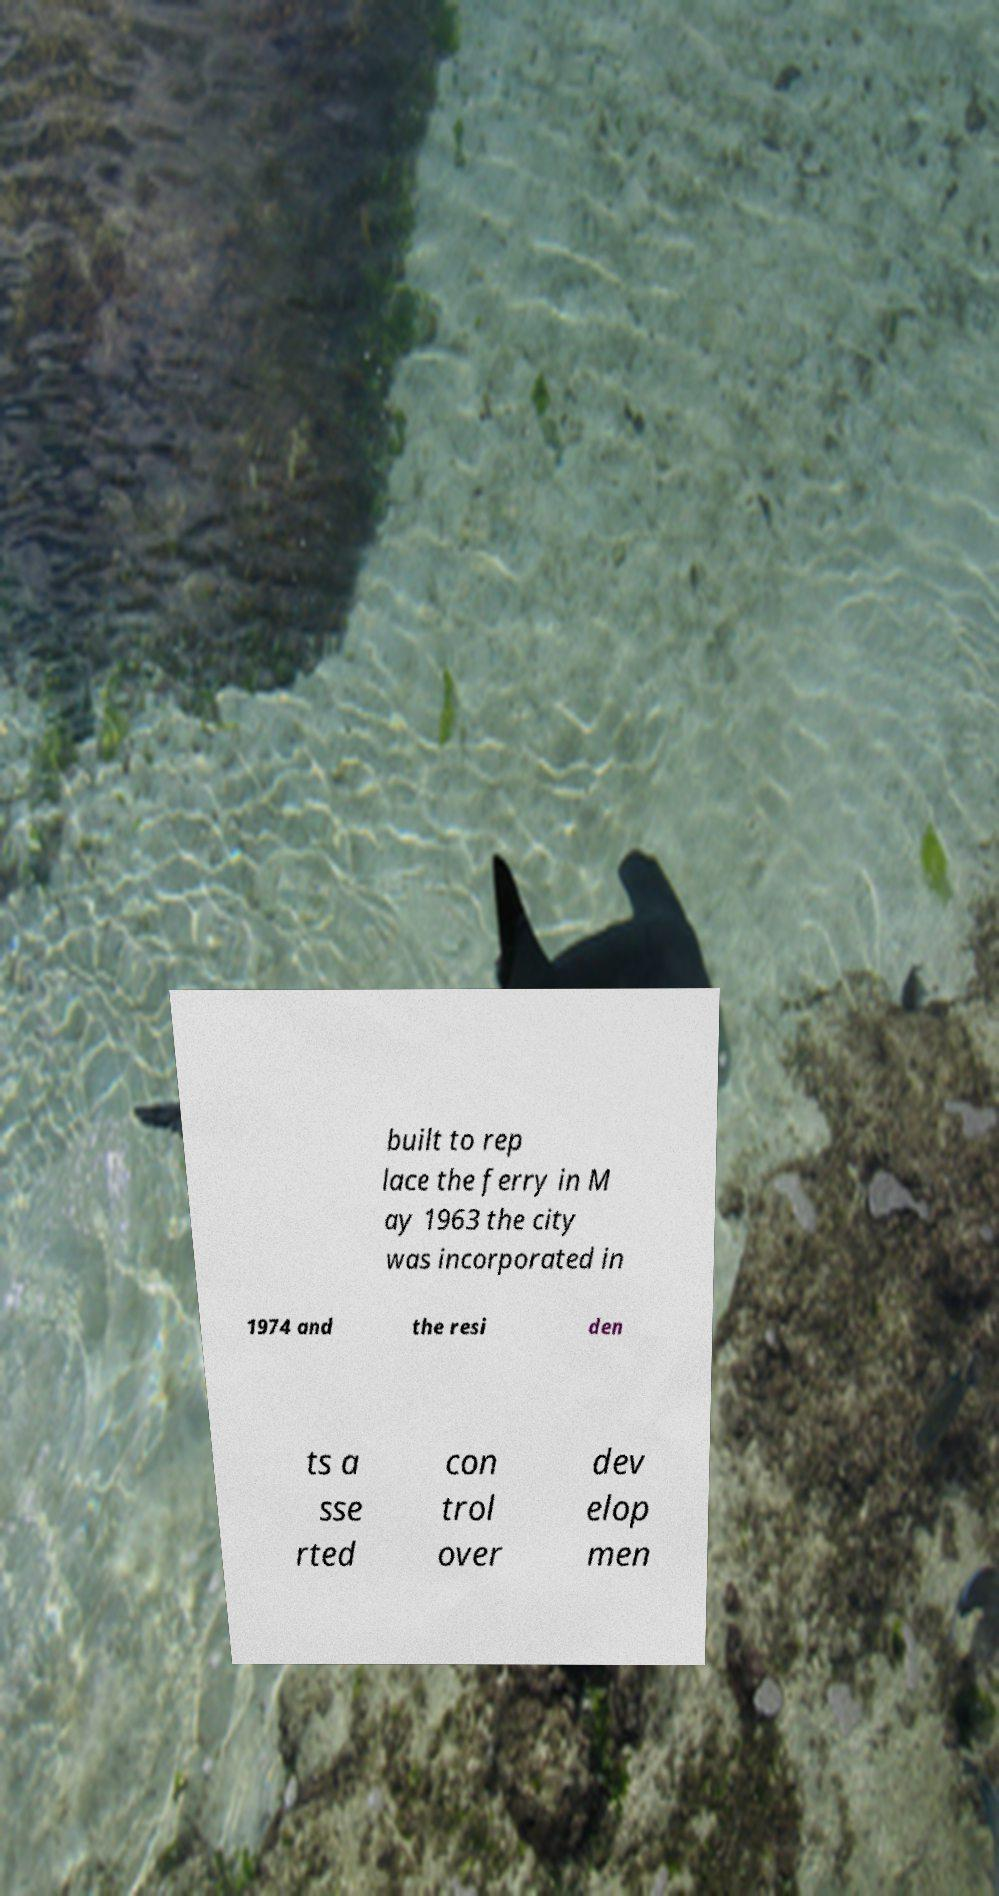Please identify and transcribe the text found in this image. built to rep lace the ferry in M ay 1963 the city was incorporated in 1974 and the resi den ts a sse rted con trol over dev elop men 